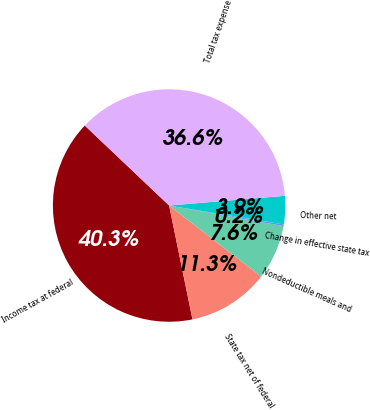Convert chart. <chart><loc_0><loc_0><loc_500><loc_500><pie_chart><fcel>Income tax at federal<fcel>State tax net of federal<fcel>Nondeductible meals and<fcel>Change in effective state tax<fcel>Other net<fcel>Total tax expense<nl><fcel>40.29%<fcel>11.32%<fcel>7.63%<fcel>0.23%<fcel>3.93%<fcel>36.59%<nl></chart> 